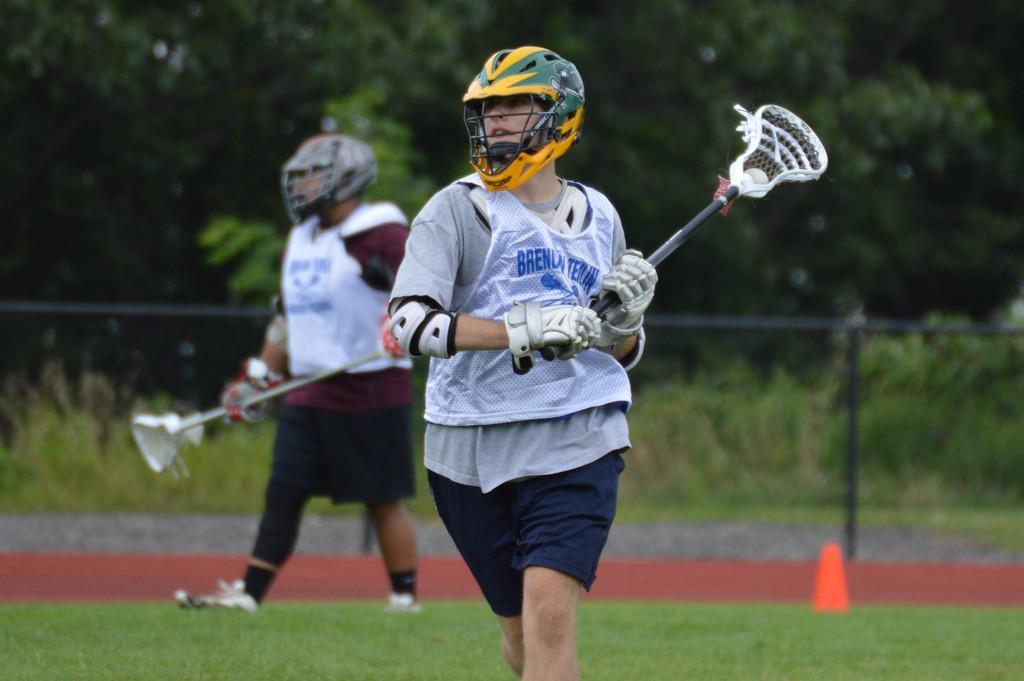Can you describe this image briefly? Background portion of the picture is blurred we can see trees and plants. In this picture we can see fence, orange object, grass. We can see men wearing helmets, gloves and holding lacrosse sticks in their hands. 